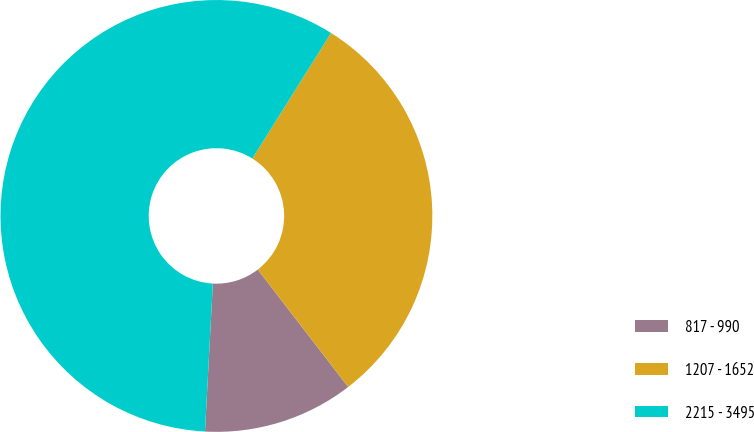<chart> <loc_0><loc_0><loc_500><loc_500><pie_chart><fcel>817 - 990<fcel>1207 - 1652<fcel>2215 - 3495<nl><fcel>11.29%<fcel>30.65%<fcel>58.06%<nl></chart> 